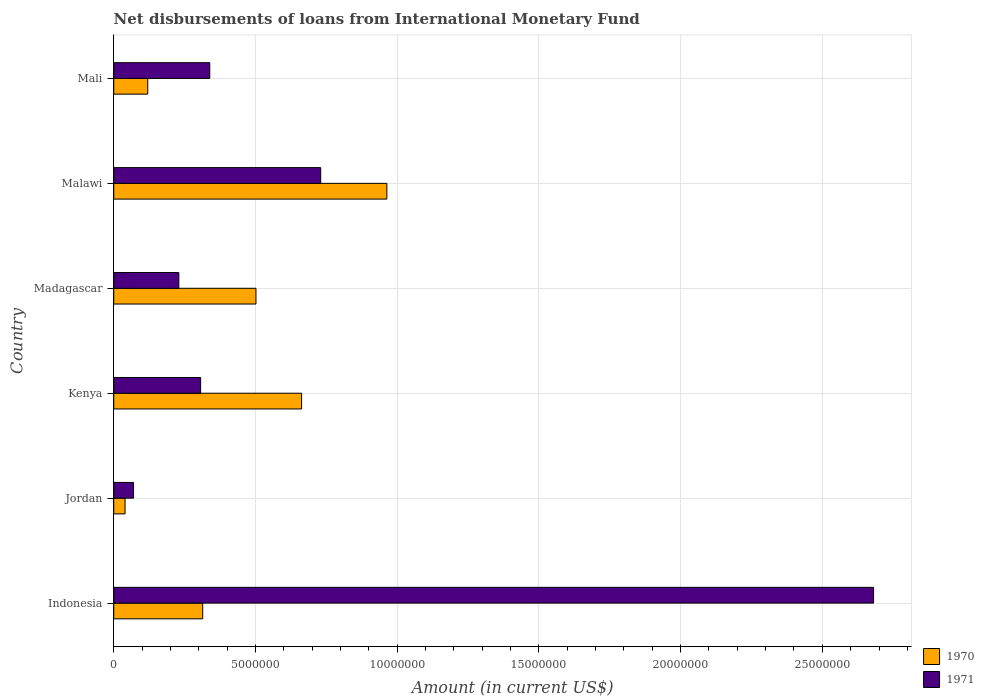How many different coloured bars are there?
Make the answer very short. 2. How many groups of bars are there?
Make the answer very short. 6. How many bars are there on the 4th tick from the bottom?
Ensure brevity in your answer.  2. What is the label of the 4th group of bars from the top?
Make the answer very short. Kenya. In how many cases, is the number of bars for a given country not equal to the number of legend labels?
Offer a very short reply. 0. What is the amount of loans disbursed in 1970 in Malawi?
Your answer should be very brief. 9.64e+06. Across all countries, what is the maximum amount of loans disbursed in 1971?
Keep it short and to the point. 2.68e+07. Across all countries, what is the minimum amount of loans disbursed in 1970?
Provide a succinct answer. 3.99e+05. In which country was the amount of loans disbursed in 1970 maximum?
Provide a short and direct response. Malawi. In which country was the amount of loans disbursed in 1970 minimum?
Give a very brief answer. Jordan. What is the total amount of loans disbursed in 1971 in the graph?
Your answer should be compact. 4.36e+07. What is the difference between the amount of loans disbursed in 1971 in Indonesia and that in Mali?
Keep it short and to the point. 2.34e+07. What is the difference between the amount of loans disbursed in 1970 in Indonesia and the amount of loans disbursed in 1971 in Mali?
Keep it short and to the point. -2.49e+05. What is the average amount of loans disbursed in 1971 per country?
Your answer should be compact. 7.26e+06. What is the ratio of the amount of loans disbursed in 1971 in Madagascar to that in Mali?
Provide a short and direct response. 0.68. Is the difference between the amount of loans disbursed in 1971 in Madagascar and Malawi greater than the difference between the amount of loans disbursed in 1970 in Madagascar and Malawi?
Offer a terse response. No. What is the difference between the highest and the second highest amount of loans disbursed in 1971?
Ensure brevity in your answer.  1.95e+07. What is the difference between the highest and the lowest amount of loans disbursed in 1970?
Keep it short and to the point. 9.24e+06. What does the 1st bar from the bottom in Kenya represents?
Provide a short and direct response. 1970. Are all the bars in the graph horizontal?
Give a very brief answer. Yes. Are the values on the major ticks of X-axis written in scientific E-notation?
Offer a very short reply. No. Does the graph contain any zero values?
Your answer should be very brief. No. Where does the legend appear in the graph?
Give a very brief answer. Bottom right. What is the title of the graph?
Keep it short and to the point. Net disbursements of loans from International Monetary Fund. What is the label or title of the X-axis?
Offer a very short reply. Amount (in current US$). What is the label or title of the Y-axis?
Your response must be concise. Country. What is the Amount (in current US$) of 1970 in Indonesia?
Your response must be concise. 3.14e+06. What is the Amount (in current US$) in 1971 in Indonesia?
Provide a succinct answer. 2.68e+07. What is the Amount (in current US$) in 1970 in Jordan?
Keep it short and to the point. 3.99e+05. What is the Amount (in current US$) in 1971 in Jordan?
Give a very brief answer. 6.99e+05. What is the Amount (in current US$) of 1970 in Kenya?
Your answer should be very brief. 6.63e+06. What is the Amount (in current US$) of 1971 in Kenya?
Offer a terse response. 3.07e+06. What is the Amount (in current US$) in 1970 in Madagascar?
Ensure brevity in your answer.  5.02e+06. What is the Amount (in current US$) of 1971 in Madagascar?
Your answer should be compact. 2.30e+06. What is the Amount (in current US$) in 1970 in Malawi?
Your answer should be compact. 9.64e+06. What is the Amount (in current US$) in 1971 in Malawi?
Provide a short and direct response. 7.30e+06. What is the Amount (in current US$) of 1970 in Mali?
Keep it short and to the point. 1.20e+06. What is the Amount (in current US$) of 1971 in Mali?
Ensure brevity in your answer.  3.39e+06. Across all countries, what is the maximum Amount (in current US$) of 1970?
Offer a terse response. 9.64e+06. Across all countries, what is the maximum Amount (in current US$) of 1971?
Ensure brevity in your answer.  2.68e+07. Across all countries, what is the minimum Amount (in current US$) in 1970?
Your response must be concise. 3.99e+05. Across all countries, what is the minimum Amount (in current US$) of 1971?
Make the answer very short. 6.99e+05. What is the total Amount (in current US$) in 1970 in the graph?
Your response must be concise. 2.60e+07. What is the total Amount (in current US$) in 1971 in the graph?
Your response must be concise. 4.36e+07. What is the difference between the Amount (in current US$) in 1970 in Indonesia and that in Jordan?
Make the answer very short. 2.74e+06. What is the difference between the Amount (in current US$) in 1971 in Indonesia and that in Jordan?
Ensure brevity in your answer.  2.61e+07. What is the difference between the Amount (in current US$) of 1970 in Indonesia and that in Kenya?
Your response must be concise. -3.49e+06. What is the difference between the Amount (in current US$) in 1971 in Indonesia and that in Kenya?
Your answer should be compact. 2.37e+07. What is the difference between the Amount (in current US$) of 1970 in Indonesia and that in Madagascar?
Ensure brevity in your answer.  -1.88e+06. What is the difference between the Amount (in current US$) in 1971 in Indonesia and that in Madagascar?
Give a very brief answer. 2.45e+07. What is the difference between the Amount (in current US$) of 1970 in Indonesia and that in Malawi?
Provide a short and direct response. -6.50e+06. What is the difference between the Amount (in current US$) in 1971 in Indonesia and that in Malawi?
Offer a very short reply. 1.95e+07. What is the difference between the Amount (in current US$) of 1970 in Indonesia and that in Mali?
Provide a succinct answer. 1.94e+06. What is the difference between the Amount (in current US$) of 1971 in Indonesia and that in Mali?
Offer a terse response. 2.34e+07. What is the difference between the Amount (in current US$) of 1970 in Jordan and that in Kenya?
Offer a terse response. -6.23e+06. What is the difference between the Amount (in current US$) of 1971 in Jordan and that in Kenya?
Your response must be concise. -2.37e+06. What is the difference between the Amount (in current US$) in 1970 in Jordan and that in Madagascar?
Ensure brevity in your answer.  -4.62e+06. What is the difference between the Amount (in current US$) of 1971 in Jordan and that in Madagascar?
Provide a short and direct response. -1.60e+06. What is the difference between the Amount (in current US$) in 1970 in Jordan and that in Malawi?
Your response must be concise. -9.24e+06. What is the difference between the Amount (in current US$) in 1971 in Jordan and that in Malawi?
Provide a short and direct response. -6.60e+06. What is the difference between the Amount (in current US$) in 1970 in Jordan and that in Mali?
Offer a very short reply. -8.01e+05. What is the difference between the Amount (in current US$) in 1971 in Jordan and that in Mali?
Your answer should be very brief. -2.69e+06. What is the difference between the Amount (in current US$) of 1970 in Kenya and that in Madagascar?
Offer a very short reply. 1.61e+06. What is the difference between the Amount (in current US$) of 1971 in Kenya and that in Madagascar?
Offer a very short reply. 7.69e+05. What is the difference between the Amount (in current US$) in 1970 in Kenya and that in Malawi?
Ensure brevity in your answer.  -3.01e+06. What is the difference between the Amount (in current US$) in 1971 in Kenya and that in Malawi?
Your response must be concise. -4.24e+06. What is the difference between the Amount (in current US$) in 1970 in Kenya and that in Mali?
Make the answer very short. 5.43e+06. What is the difference between the Amount (in current US$) of 1971 in Kenya and that in Mali?
Keep it short and to the point. -3.22e+05. What is the difference between the Amount (in current US$) of 1970 in Madagascar and that in Malawi?
Provide a succinct answer. -4.62e+06. What is the difference between the Amount (in current US$) in 1971 in Madagascar and that in Malawi?
Offer a terse response. -5.00e+06. What is the difference between the Amount (in current US$) in 1970 in Madagascar and that in Mali?
Keep it short and to the point. 3.82e+06. What is the difference between the Amount (in current US$) of 1971 in Madagascar and that in Mali?
Offer a terse response. -1.09e+06. What is the difference between the Amount (in current US$) of 1970 in Malawi and that in Mali?
Offer a terse response. 8.44e+06. What is the difference between the Amount (in current US$) of 1971 in Malawi and that in Mali?
Your answer should be compact. 3.91e+06. What is the difference between the Amount (in current US$) of 1970 in Indonesia and the Amount (in current US$) of 1971 in Jordan?
Your answer should be very brief. 2.44e+06. What is the difference between the Amount (in current US$) in 1970 in Indonesia and the Amount (in current US$) in 1971 in Kenya?
Your answer should be compact. 7.30e+04. What is the difference between the Amount (in current US$) of 1970 in Indonesia and the Amount (in current US$) of 1971 in Madagascar?
Provide a short and direct response. 8.42e+05. What is the difference between the Amount (in current US$) of 1970 in Indonesia and the Amount (in current US$) of 1971 in Malawi?
Provide a short and direct response. -4.16e+06. What is the difference between the Amount (in current US$) of 1970 in Indonesia and the Amount (in current US$) of 1971 in Mali?
Provide a short and direct response. -2.49e+05. What is the difference between the Amount (in current US$) in 1970 in Jordan and the Amount (in current US$) in 1971 in Kenya?
Your answer should be compact. -2.67e+06. What is the difference between the Amount (in current US$) in 1970 in Jordan and the Amount (in current US$) in 1971 in Madagascar?
Offer a very short reply. -1.90e+06. What is the difference between the Amount (in current US$) of 1970 in Jordan and the Amount (in current US$) of 1971 in Malawi?
Your response must be concise. -6.90e+06. What is the difference between the Amount (in current US$) in 1970 in Jordan and the Amount (in current US$) in 1971 in Mali?
Offer a terse response. -2.99e+06. What is the difference between the Amount (in current US$) in 1970 in Kenya and the Amount (in current US$) in 1971 in Madagascar?
Your answer should be very brief. 4.33e+06. What is the difference between the Amount (in current US$) of 1970 in Kenya and the Amount (in current US$) of 1971 in Malawi?
Provide a short and direct response. -6.74e+05. What is the difference between the Amount (in current US$) of 1970 in Kenya and the Amount (in current US$) of 1971 in Mali?
Make the answer very short. 3.24e+06. What is the difference between the Amount (in current US$) in 1970 in Madagascar and the Amount (in current US$) in 1971 in Malawi?
Give a very brief answer. -2.28e+06. What is the difference between the Amount (in current US$) of 1970 in Madagascar and the Amount (in current US$) of 1971 in Mali?
Give a very brief answer. 1.63e+06. What is the difference between the Amount (in current US$) in 1970 in Malawi and the Amount (in current US$) in 1971 in Mali?
Make the answer very short. 6.25e+06. What is the average Amount (in current US$) of 1970 per country?
Your answer should be compact. 4.34e+06. What is the average Amount (in current US$) of 1971 per country?
Ensure brevity in your answer.  7.26e+06. What is the difference between the Amount (in current US$) of 1970 and Amount (in current US$) of 1971 in Indonesia?
Your answer should be very brief. -2.37e+07. What is the difference between the Amount (in current US$) of 1970 and Amount (in current US$) of 1971 in Jordan?
Ensure brevity in your answer.  -3.00e+05. What is the difference between the Amount (in current US$) of 1970 and Amount (in current US$) of 1971 in Kenya?
Give a very brief answer. 3.56e+06. What is the difference between the Amount (in current US$) of 1970 and Amount (in current US$) of 1971 in Madagascar?
Your response must be concise. 2.72e+06. What is the difference between the Amount (in current US$) of 1970 and Amount (in current US$) of 1971 in Malawi?
Your answer should be very brief. 2.33e+06. What is the difference between the Amount (in current US$) of 1970 and Amount (in current US$) of 1971 in Mali?
Your response must be concise. -2.19e+06. What is the ratio of the Amount (in current US$) in 1970 in Indonesia to that in Jordan?
Give a very brief answer. 7.87. What is the ratio of the Amount (in current US$) of 1971 in Indonesia to that in Jordan?
Keep it short and to the point. 38.35. What is the ratio of the Amount (in current US$) in 1970 in Indonesia to that in Kenya?
Provide a short and direct response. 0.47. What is the ratio of the Amount (in current US$) in 1971 in Indonesia to that in Kenya?
Your answer should be very brief. 8.74. What is the ratio of the Amount (in current US$) in 1970 in Indonesia to that in Madagascar?
Make the answer very short. 0.63. What is the ratio of the Amount (in current US$) in 1971 in Indonesia to that in Madagascar?
Offer a very short reply. 11.67. What is the ratio of the Amount (in current US$) of 1970 in Indonesia to that in Malawi?
Your response must be concise. 0.33. What is the ratio of the Amount (in current US$) in 1971 in Indonesia to that in Malawi?
Your answer should be compact. 3.67. What is the ratio of the Amount (in current US$) in 1970 in Indonesia to that in Mali?
Keep it short and to the point. 2.62. What is the ratio of the Amount (in current US$) in 1971 in Indonesia to that in Mali?
Offer a terse response. 7.91. What is the ratio of the Amount (in current US$) of 1970 in Jordan to that in Kenya?
Ensure brevity in your answer.  0.06. What is the ratio of the Amount (in current US$) of 1971 in Jordan to that in Kenya?
Provide a short and direct response. 0.23. What is the ratio of the Amount (in current US$) of 1970 in Jordan to that in Madagascar?
Provide a short and direct response. 0.08. What is the ratio of the Amount (in current US$) in 1971 in Jordan to that in Madagascar?
Provide a succinct answer. 0.3. What is the ratio of the Amount (in current US$) in 1970 in Jordan to that in Malawi?
Make the answer very short. 0.04. What is the ratio of the Amount (in current US$) of 1971 in Jordan to that in Malawi?
Make the answer very short. 0.1. What is the ratio of the Amount (in current US$) of 1970 in Jordan to that in Mali?
Provide a short and direct response. 0.33. What is the ratio of the Amount (in current US$) of 1971 in Jordan to that in Mali?
Offer a very short reply. 0.21. What is the ratio of the Amount (in current US$) in 1970 in Kenya to that in Madagascar?
Offer a very short reply. 1.32. What is the ratio of the Amount (in current US$) in 1971 in Kenya to that in Madagascar?
Keep it short and to the point. 1.33. What is the ratio of the Amount (in current US$) of 1970 in Kenya to that in Malawi?
Make the answer very short. 0.69. What is the ratio of the Amount (in current US$) in 1971 in Kenya to that in Malawi?
Keep it short and to the point. 0.42. What is the ratio of the Amount (in current US$) of 1970 in Kenya to that in Mali?
Make the answer very short. 5.52. What is the ratio of the Amount (in current US$) in 1971 in Kenya to that in Mali?
Make the answer very short. 0.91. What is the ratio of the Amount (in current US$) in 1970 in Madagascar to that in Malawi?
Provide a short and direct response. 0.52. What is the ratio of the Amount (in current US$) of 1971 in Madagascar to that in Malawi?
Ensure brevity in your answer.  0.31. What is the ratio of the Amount (in current US$) of 1970 in Madagascar to that in Mali?
Your answer should be compact. 4.18. What is the ratio of the Amount (in current US$) of 1971 in Madagascar to that in Mali?
Ensure brevity in your answer.  0.68. What is the ratio of the Amount (in current US$) in 1970 in Malawi to that in Mali?
Make the answer very short. 8.03. What is the ratio of the Amount (in current US$) of 1971 in Malawi to that in Mali?
Provide a succinct answer. 2.16. What is the difference between the highest and the second highest Amount (in current US$) in 1970?
Your response must be concise. 3.01e+06. What is the difference between the highest and the second highest Amount (in current US$) in 1971?
Provide a short and direct response. 1.95e+07. What is the difference between the highest and the lowest Amount (in current US$) of 1970?
Offer a very short reply. 9.24e+06. What is the difference between the highest and the lowest Amount (in current US$) in 1971?
Keep it short and to the point. 2.61e+07. 